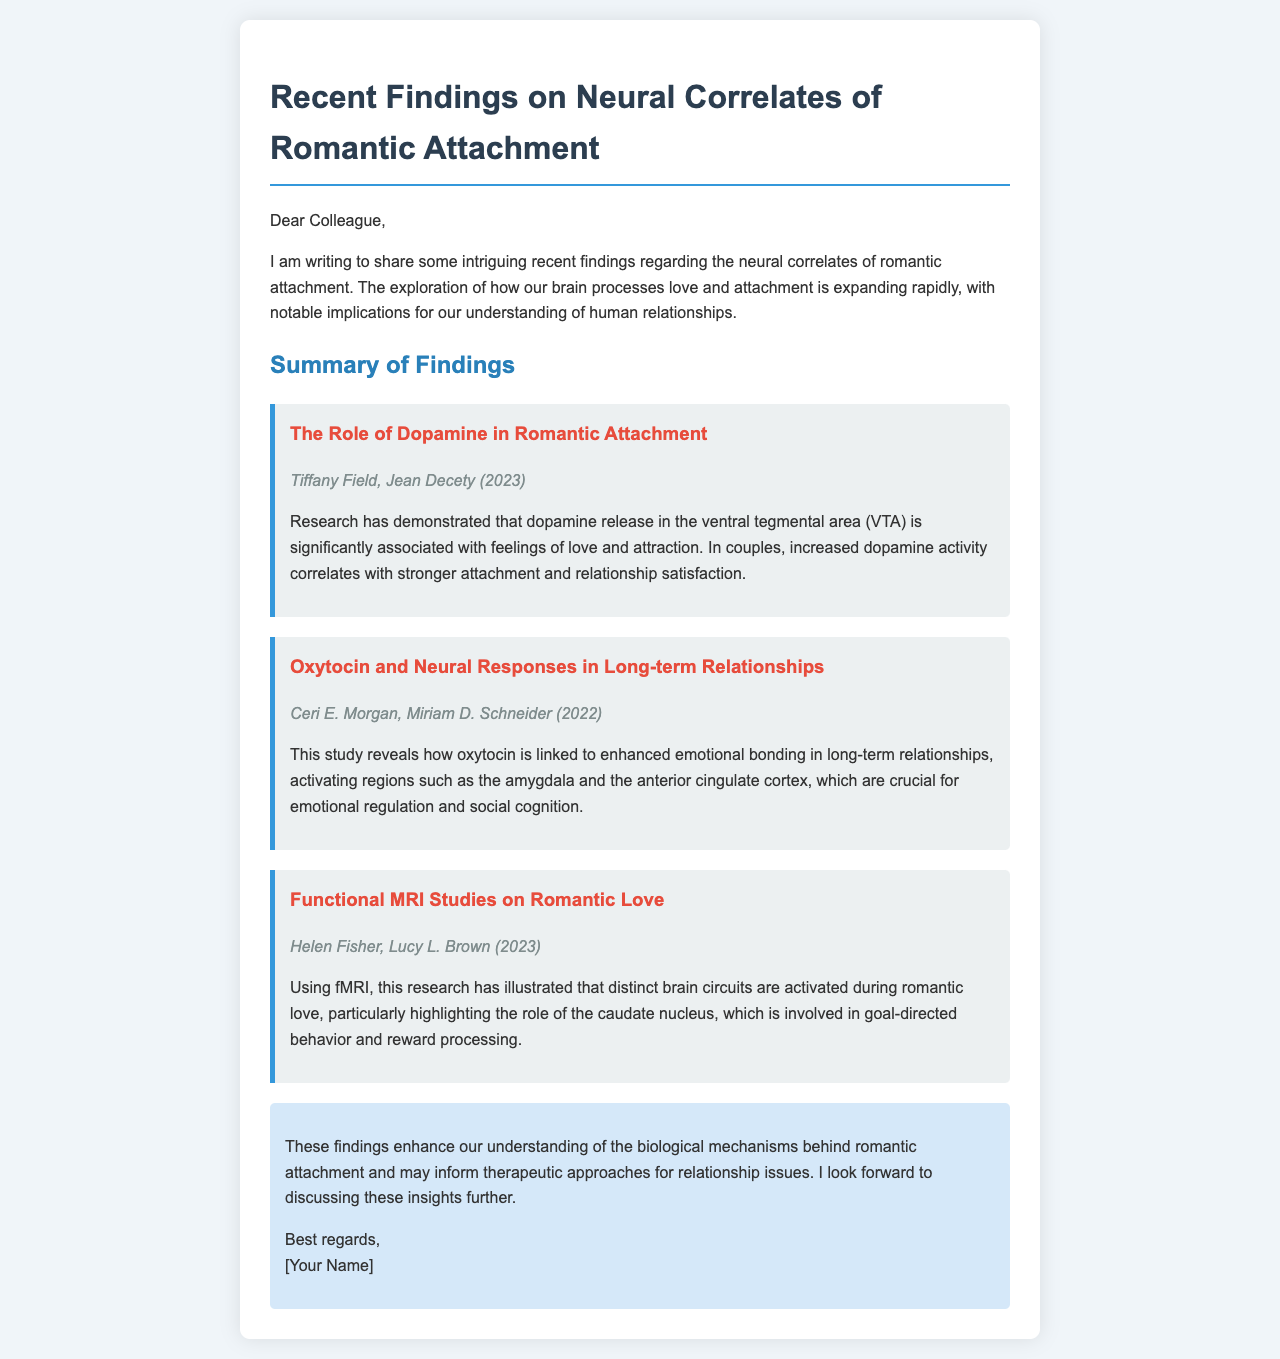What is the main topic of the email? The email discusses findings related to the biological basis of romantic attachment through recent research.
Answer: Neural correlates of romantic attachment Who authored the study on dopamine and romantic attachment? The email lists Tiffany Field and Jean Decety as the authors of the dopamine study.
Answer: Tiffany Field, Jean Decety What year was the oxytocin study published? The study on oxytocin and long-term relationships was published in 2022.
Answer: 2022 Which brain region is highlighted in the study by Fisher and Brown? The caudate nucleus is the brain region discussed in the functional MRI study on romantic love.
Answer: Caudate nucleus What does increased dopamine activity correlate with according to the findings? Increased dopamine activity correlates with stronger attachment and relationship satisfaction.
Answer: Stronger attachment and relationship satisfaction What is one key function of oxytocin as per the document? The document states that oxytocin is linked to enhanced emotional bonding in long-term relationships.
Answer: Enhanced emotional bonding What type of research method was used in the study by Fisher and Brown? The method used in their study is functional MRI, as mentioned in the email.
Answer: fMRI What implication does the conclusion suggest regarding therapy? The conclusion implies that understanding biological mechanisms may inform therapeutic approaches for relationship issues.
Answer: Inform therapeutic approaches 